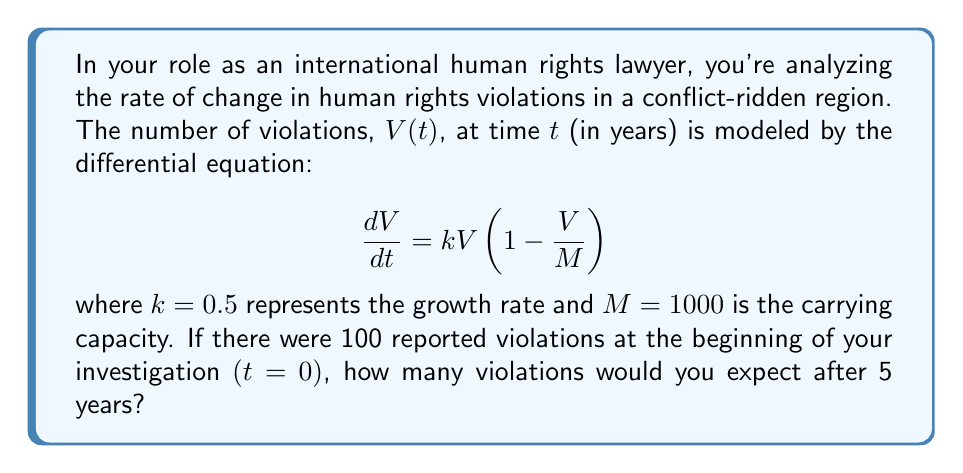What is the answer to this math problem? To solve this problem, we need to follow these steps:

1) The given differential equation is a logistic growth model:
   $$\frac{dV}{dt} = kV(1 - \frac{V}{M})$$

2) The solution to this equation is:
   $$V(t) = \frac{M}{1 + (\frac{M}{V_0} - 1)e^{-kt}}$$

   Where $V_0$ is the initial number of violations.

3) We're given:
   $k = 0.5$
   $M = 1000$
   $V_0 = 100$
   $t = 5$

4) Let's substitute these values into our solution:
   $$V(5) = \frac{1000}{1 + (\frac{1000}{100} - 1)e^{-0.5 \cdot 5}}$$

5) Simplify:
   $$V(5) = \frac{1000}{1 + 9e^{-2.5}}$$

6) Calculate:
   $$V(5) \approx 731.59$$

7) Since we're dealing with a count of violations, we round to the nearest whole number.
Answer: 732 violations 